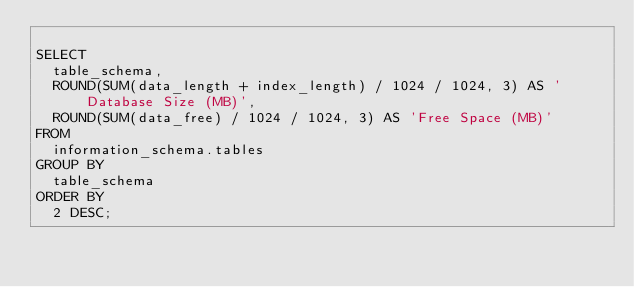Convert code to text. <code><loc_0><loc_0><loc_500><loc_500><_SQL_>
SELECT
  table_schema,
  ROUND(SUM(data_length + index_length) / 1024 / 1024, 3) AS 'Database Size (MB)',
  ROUND(SUM(data_free) / 1024 / 1024, 3) AS 'Free Space (MB)'
FROM
  information_schema.tables
GROUP BY
  table_schema
ORDER BY
  2 DESC;
</code> 